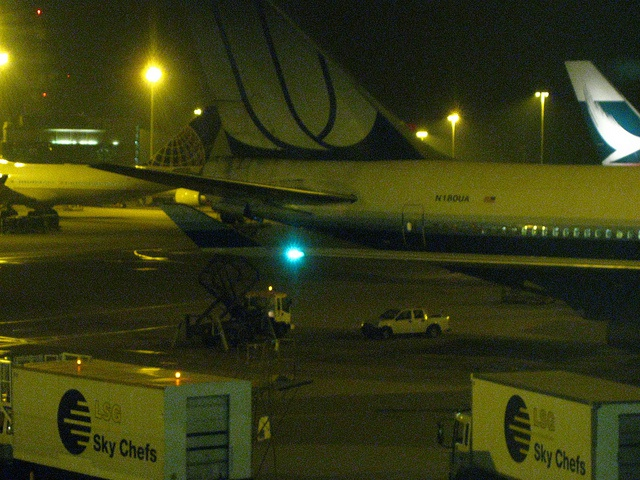Describe the objects in this image and their specific colors. I can see airplane in olive, black, darkgreen, and white tones, truck in olive, darkgreen, and black tones, truck in olive, black, and darkgreen tones, airplane in olive, black, and gold tones, and truck in olive, black, and darkgreen tones in this image. 